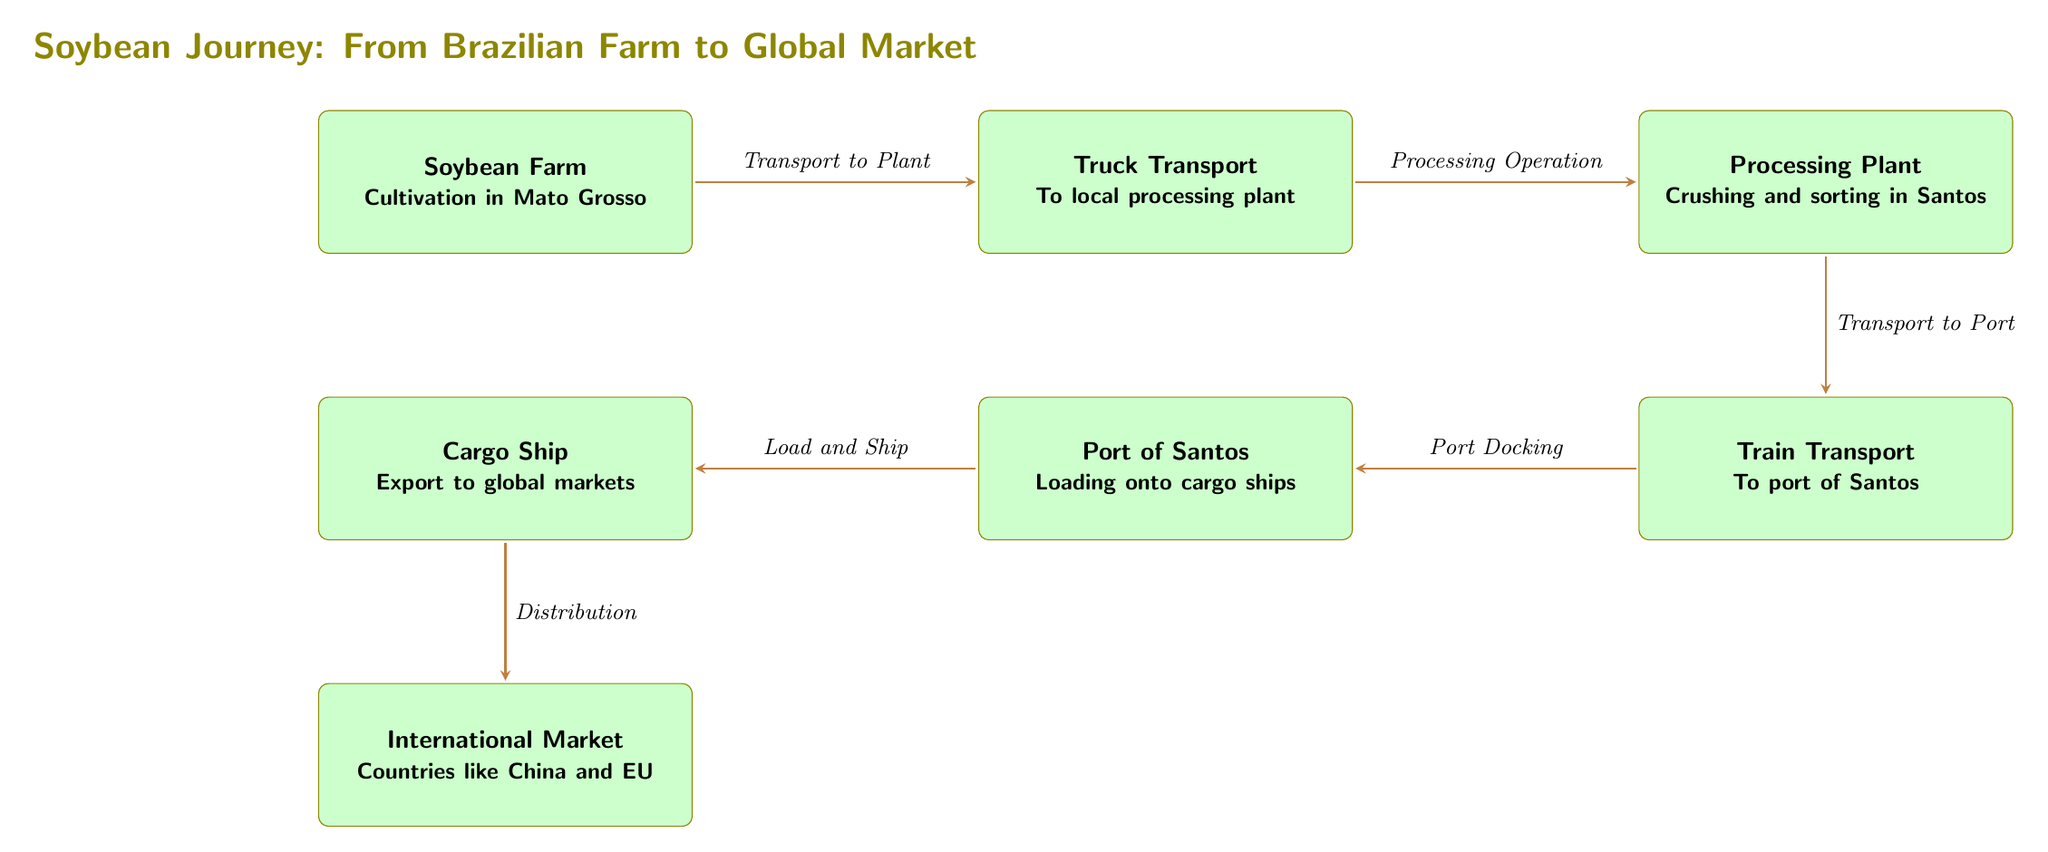What is the starting point of the soybean journey? The diagram shows the starting point as the Soybean Farm located in Mato Grosso. This is clearly labeled as the first node in the food chain.
Answer: Soybean Farm How many main nodes are in the food chain? Counting all the distinct nodes from the Soybean Farm to the International Market, there are six main nodes identified: Farm, Truck Transport, Processing Plant, Train Transport, Port, and Cargo Ship.
Answer: Six What operation occurs at the Processing Plant? The diagram explicitly states that the Processing Plant involves Crushing and sorting. This is detailed in the description within the node.
Answer: Crushing and sorting What is the transport method from the Processing Plant to the Port? The connection between the Processing Plant and the Port is labeled as Train Transport, indicating that this method is used for the journey between these nodes.
Answer: Train Transport Which international markets are mentioned for the soybean? The node labeled International Market specifies Countries like China and EU as the destinations for the soybean, indicating the global reach of this product.
Answer: China and EU How is the soybean delivered to international markets? The route from the Cargo Ship to the International Market is labeled as Distribution, indicating that this is the process through which the soybean reaches various global customers.
Answer: Distribution Why is the processing operation crucial in the journey? The Processing Plant's operations of Crushing and sorting transform the raw soybeans into products that are necessary for international trade, thereby connecting local agriculture with global demand. This transformation enhances value and marketability.
Answer: Enhances value What is the final destination in the food chain? The last node in the diagram is the International Market, which represents the endpoint of the soybean's journey from Brazil to the rest of the world.
Answer: International Market What happens between the Port of Santos and the Cargo Ship? The arrow labeled Load and Ship indicates the action that connects the Port of Santos to the Cargo Ship, depicting how the soybeans are transferred and prepared for international transport.
Answer: Load and Ship 